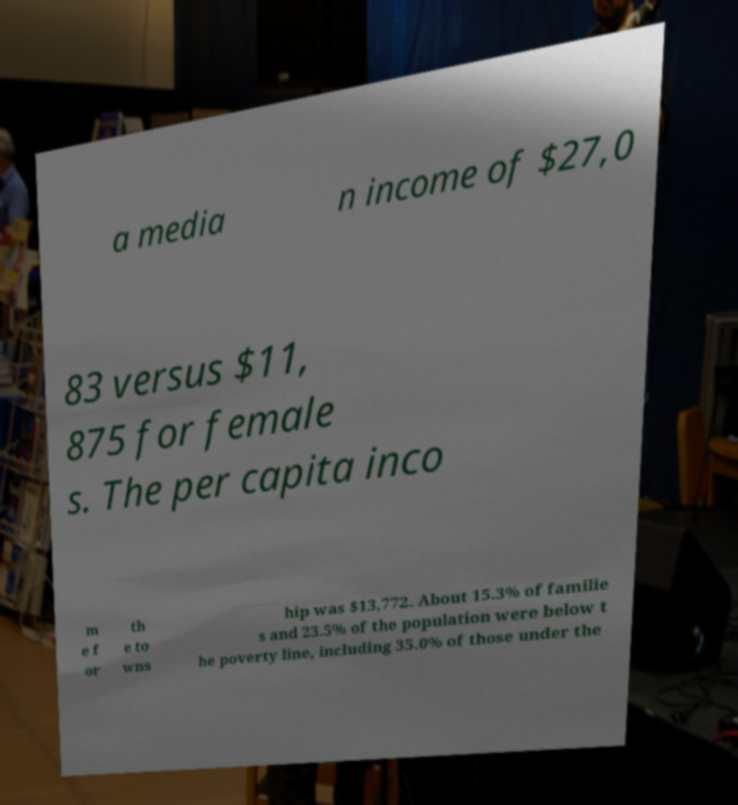Could you assist in decoding the text presented in this image and type it out clearly? a media n income of $27,0 83 versus $11, 875 for female s. The per capita inco m e f or th e to wns hip was $13,772. About 15.3% of familie s and 23.5% of the population were below t he poverty line, including 35.0% of those under the 